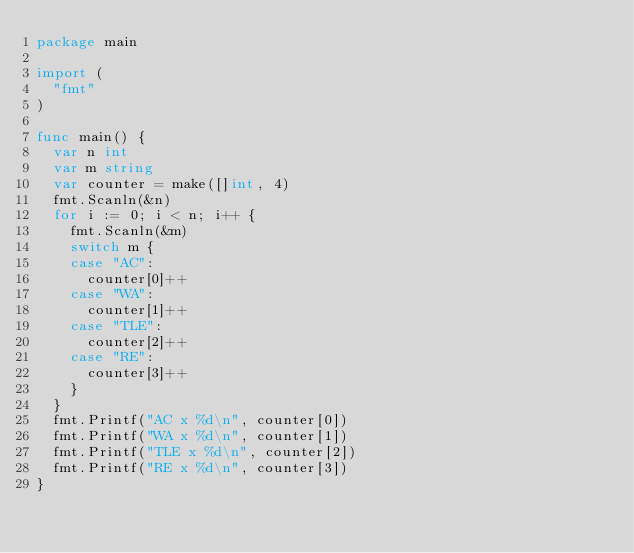Convert code to text. <code><loc_0><loc_0><loc_500><loc_500><_Go_>package main

import (
	"fmt"
)

func main() {
	var n int
	var m string
	var counter = make([]int, 4)
	fmt.Scanln(&n)
	for i := 0; i < n; i++ {
		fmt.Scanln(&m)
		switch m {
		case "AC":
			counter[0]++
		case "WA":
			counter[1]++
		case "TLE":
			counter[2]++
		case "RE":
			counter[3]++
		}
	}
	fmt.Printf("AC x %d\n", counter[0])
	fmt.Printf("WA x %d\n", counter[1])
	fmt.Printf("TLE x %d\n", counter[2])
	fmt.Printf("RE x %d\n", counter[3])
}</code> 